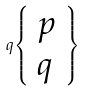Convert formula to latex. <formula><loc_0><loc_0><loc_500><loc_500>q { \left \{ \begin{array} { l } { p } \\ { q } \end{array} \right \} }</formula> 